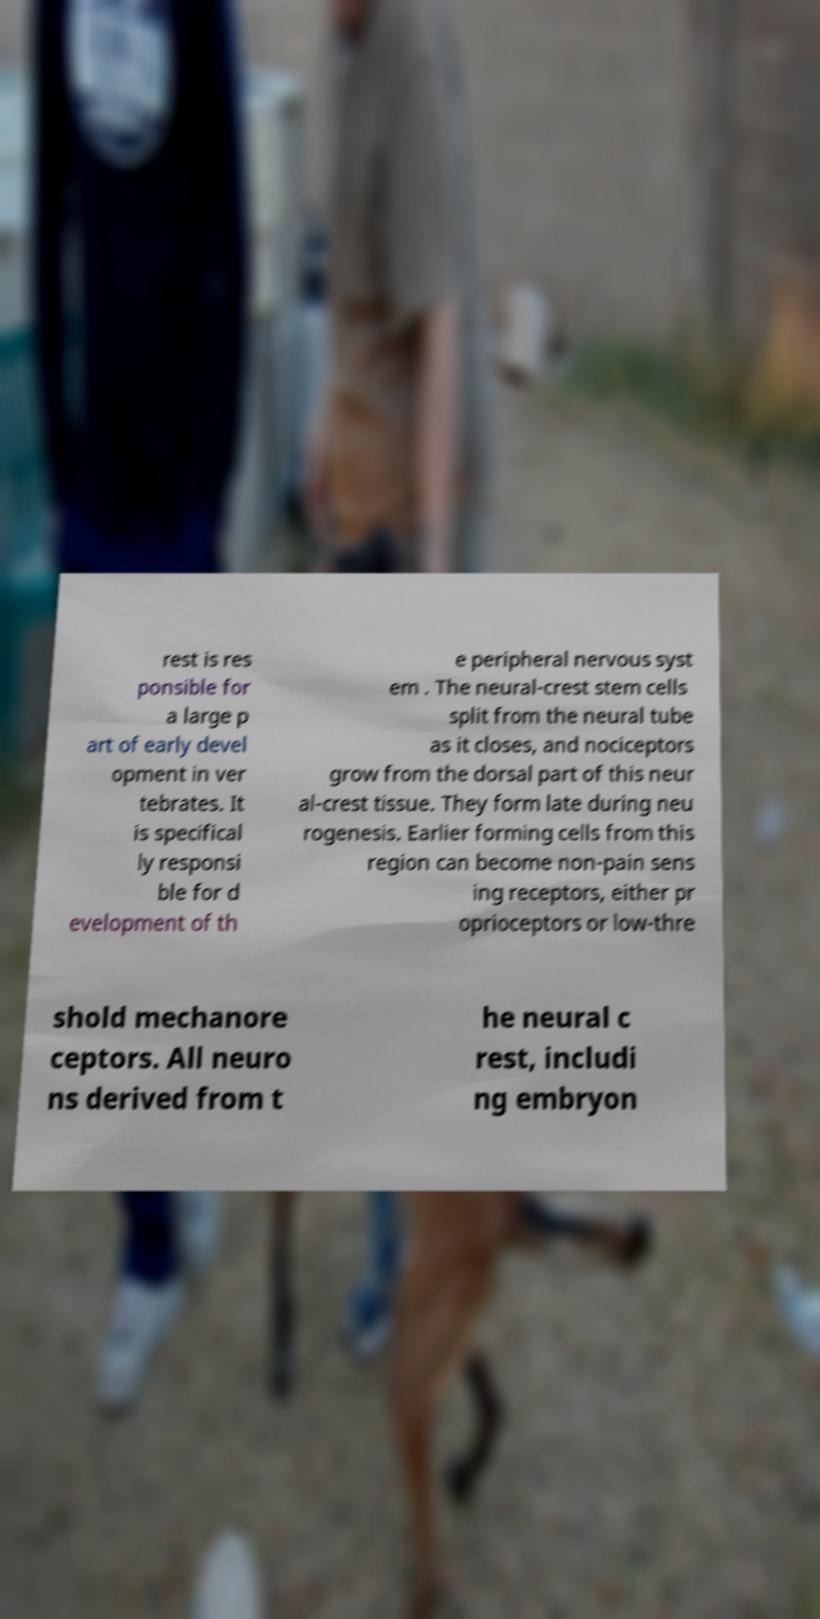I need the written content from this picture converted into text. Can you do that? rest is res ponsible for a large p art of early devel opment in ver tebrates. It is specifical ly responsi ble for d evelopment of th e peripheral nervous syst em . The neural-crest stem cells split from the neural tube as it closes, and nociceptors grow from the dorsal part of this neur al-crest tissue. They form late during neu rogenesis. Earlier forming cells from this region can become non-pain sens ing receptors, either pr oprioceptors or low-thre shold mechanore ceptors. All neuro ns derived from t he neural c rest, includi ng embryon 